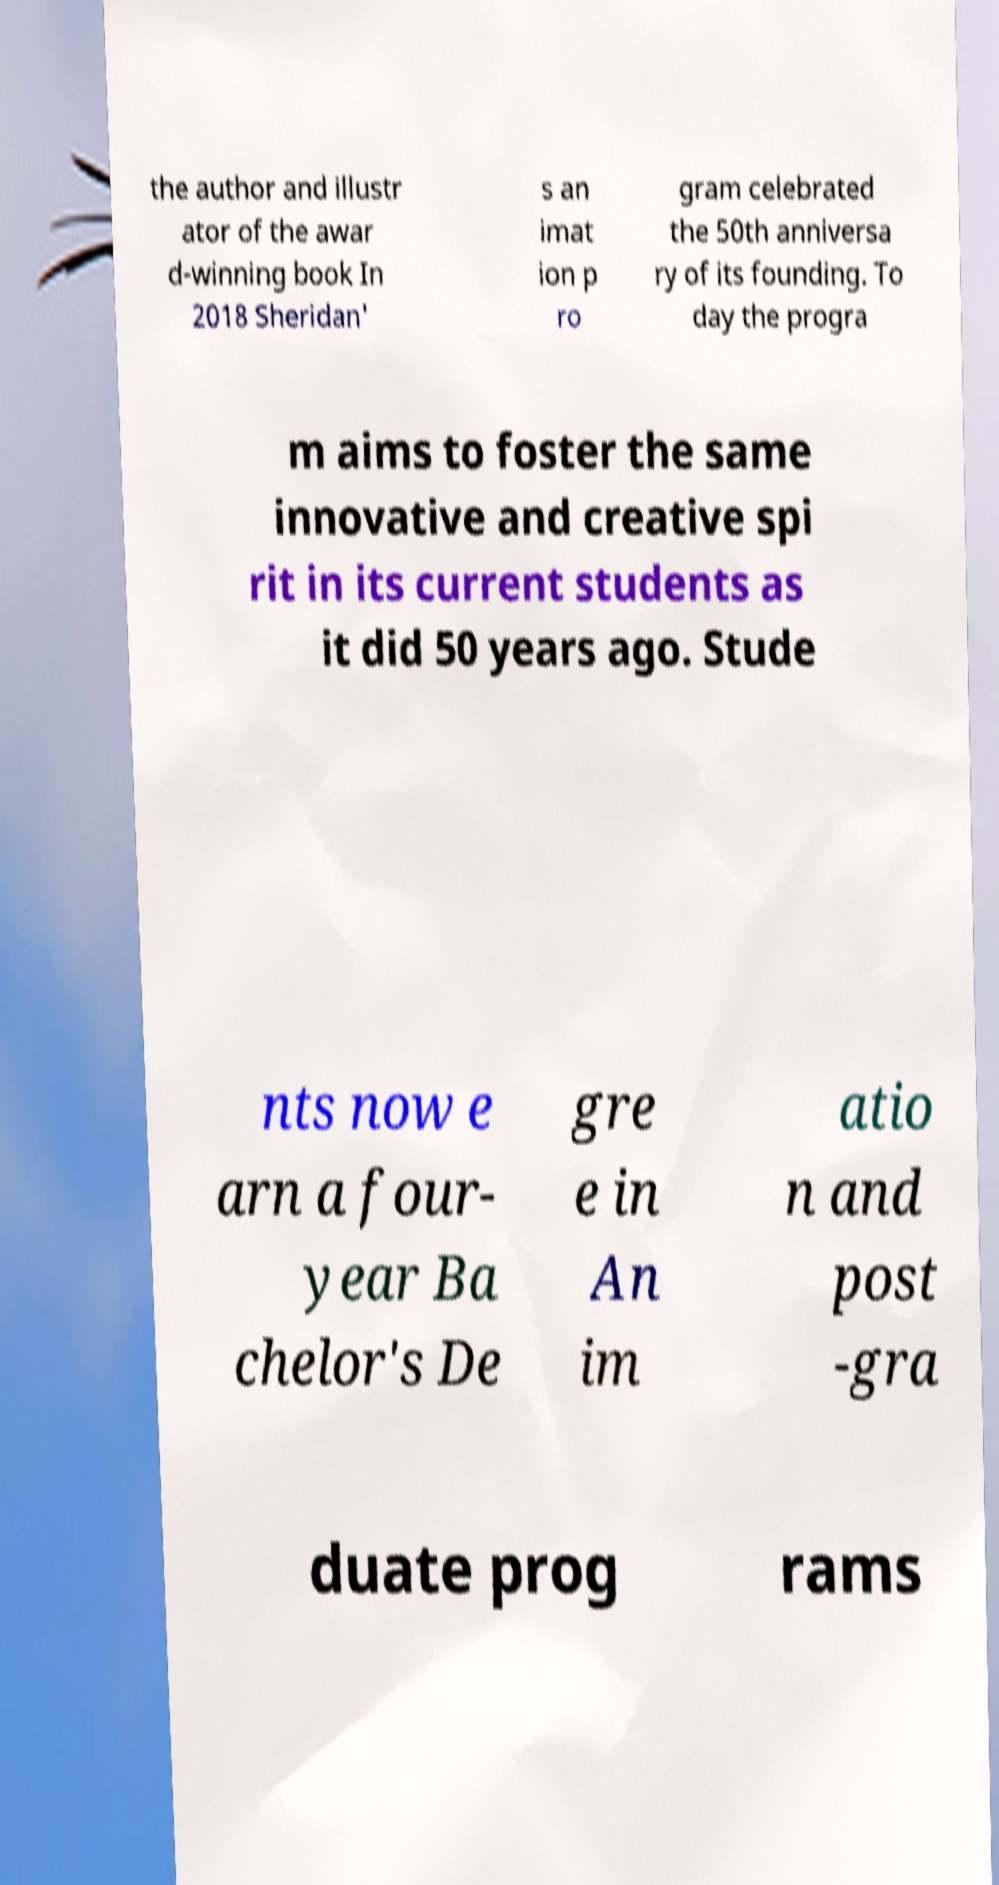For documentation purposes, I need the text within this image transcribed. Could you provide that? the author and illustr ator of the awar d-winning book In 2018 Sheridan' s an imat ion p ro gram celebrated the 50th anniversa ry of its founding. To day the progra m aims to foster the same innovative and creative spi rit in its current students as it did 50 years ago. Stude nts now e arn a four- year Ba chelor's De gre e in An im atio n and post -gra duate prog rams 